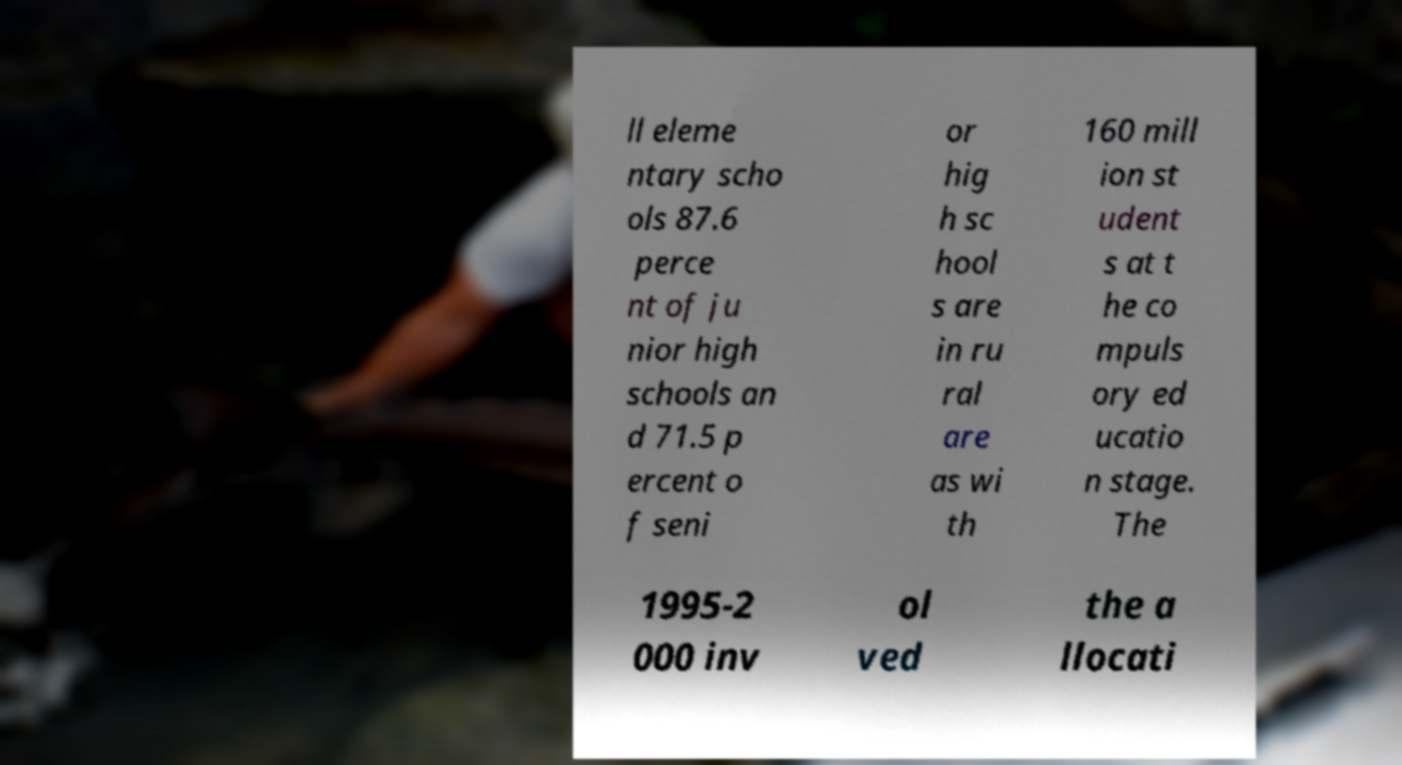There's text embedded in this image that I need extracted. Can you transcribe it verbatim? ll eleme ntary scho ols 87.6 perce nt of ju nior high schools an d 71.5 p ercent o f seni or hig h sc hool s are in ru ral are as wi th 160 mill ion st udent s at t he co mpuls ory ed ucatio n stage. The 1995-2 000 inv ol ved the a llocati 